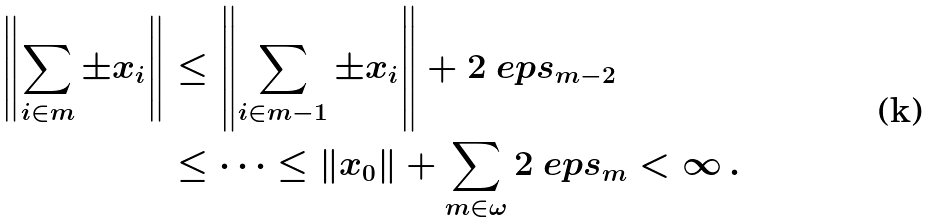<formula> <loc_0><loc_0><loc_500><loc_500>\left \| \sum _ { i \in m } \pm x _ { i } \right \| & \leq \left \| \sum _ { i \in m - 1 } \pm x _ { i } \right \| + 2 \ e p s _ { m - 2 } \\ & \leq \cdots \leq \| x _ { 0 } \| + \sum _ { m \in \omega } 2 \ e p s _ { m } < \infty \, .</formula> 